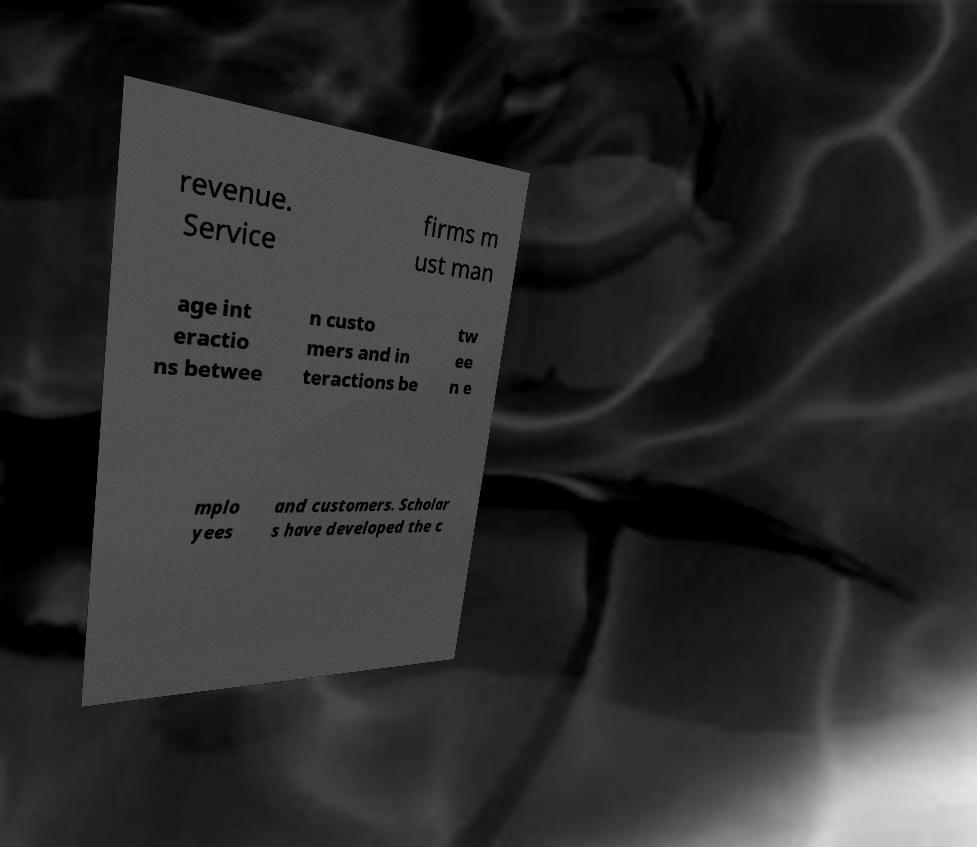What messages or text are displayed in this image? I need them in a readable, typed format. revenue. Service firms m ust man age int eractio ns betwee n custo mers and in teractions be tw ee n e mplo yees and customers. Scholar s have developed the c 